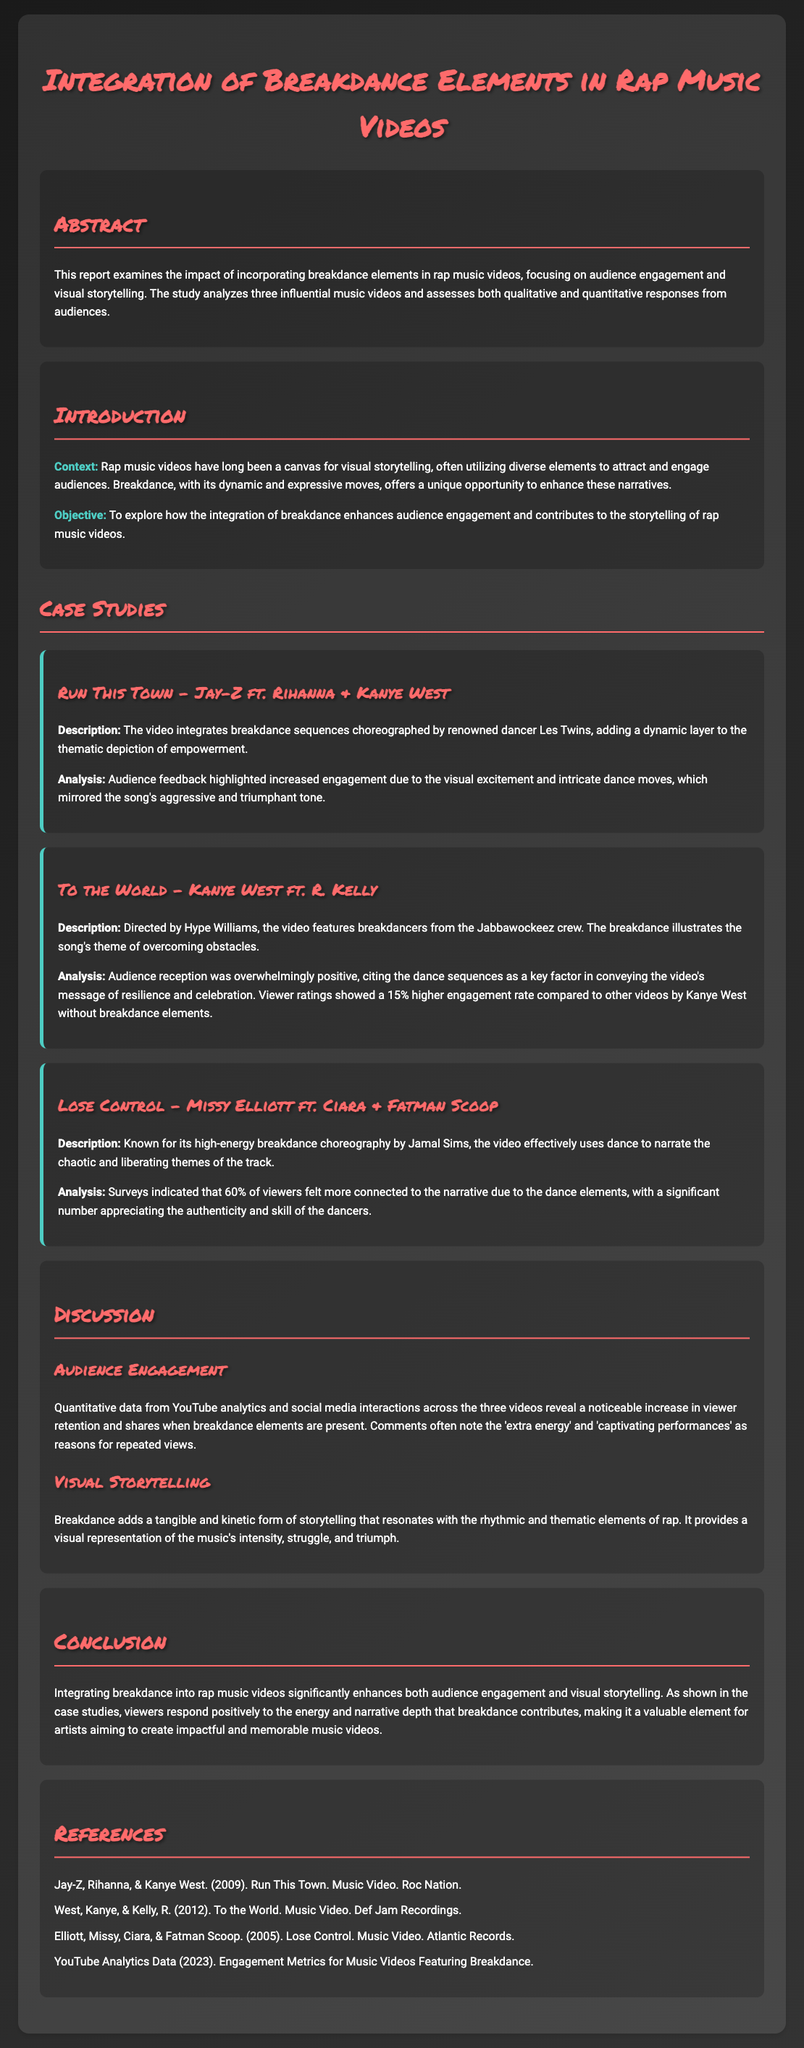What is the main focus of the report? The report examines the impact of incorporating breakdance elements in rap music videos, focusing on audience engagement and visual storytelling.
Answer: Audience engagement and visual storytelling Who are the featured artists in "Run This Town"? The video features Jay-Z, Rihanna, and Kanye West.
Answer: Jay-Z, Rihanna, and Kanye West What percentage of viewers felt more connected due to the dance elements in "Lose Control"? Surveys indicated that 60% of viewers felt more connected to the narrative due to the dance elements.
Answer: 60% Which dance crew is associated with "To the World"? The video features breakdancers from the Jabbawockeez crew.
Answer: Jabbawockeez How much higher was the engagement rate for "To the World" compared to other videos? Viewer ratings showed a 15% higher engagement rate compared to other videos by Kanye West without breakdance elements.
Answer: 15% What type of data was used to analyze audience engagement? Quantitative data from YouTube analytics and social media interactions was used to reveal a noticeable increase in viewer retention and shares when breakdance elements are present.
Answer: YouTube analytics and social media interactions What role does breakdance play in visual storytelling according to the report? Breakdance adds a tangible and kinetic form of storytelling that resonates with the rhythmic and thematic elements of rap.
Answer: Tangible and kinetic storytelling What year was "Lose Control" released? The music video for "Lose Control" was released in 2005.
Answer: 2005 What does the conclusion suggest about integrating breakdance into rap videos? Integrating breakdance into rap music videos significantly enhances both audience engagement and visual storytelling.
Answer: Significantly enhances engagement and storytelling 